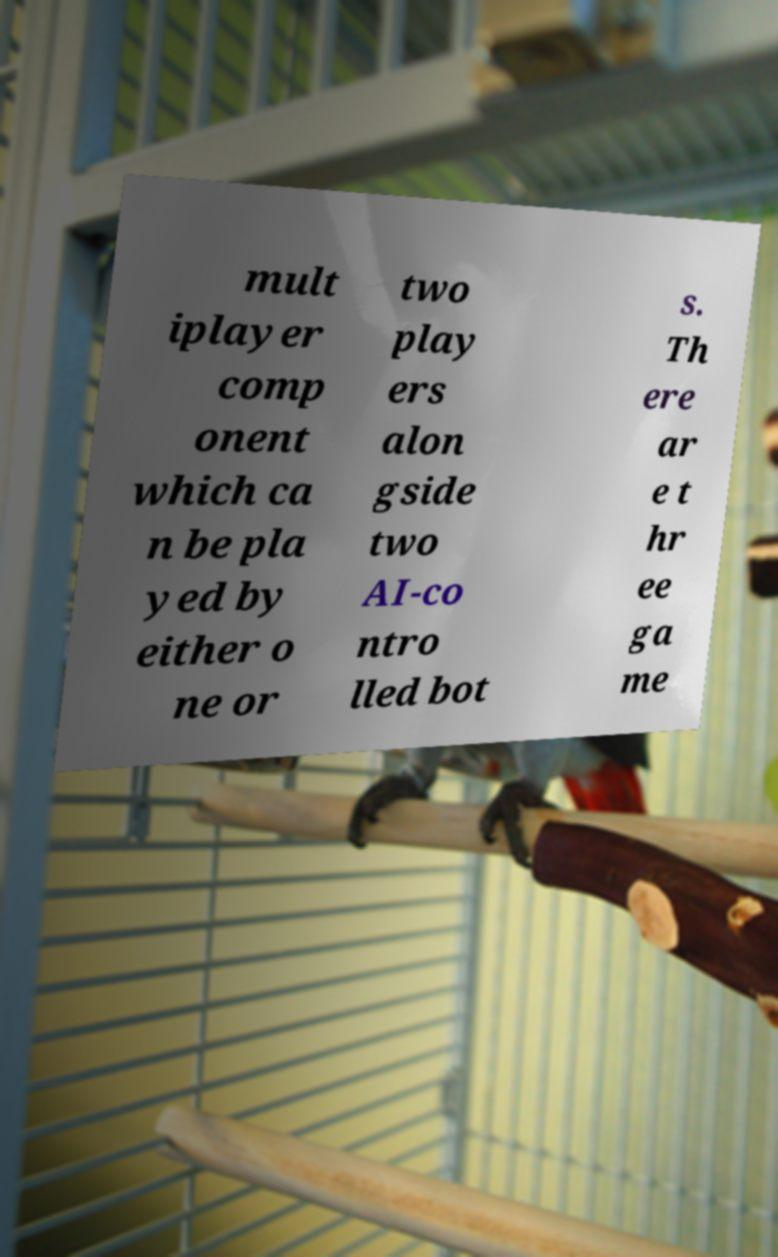Can you accurately transcribe the text from the provided image for me? mult iplayer comp onent which ca n be pla yed by either o ne or two play ers alon gside two AI-co ntro lled bot s. Th ere ar e t hr ee ga me 